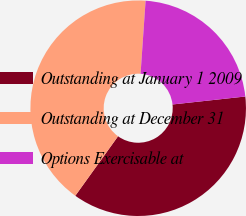Convert chart. <chart><loc_0><loc_0><loc_500><loc_500><pie_chart><fcel>Outstanding at January 1 2009<fcel>Outstanding at December 31<fcel>Options Exercisable at<nl><fcel>36.65%<fcel>41.18%<fcel>22.17%<nl></chart> 